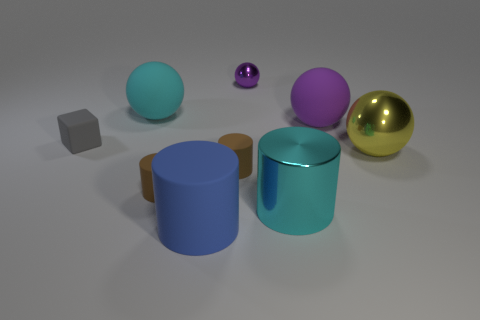What is the material of the tiny purple ball?
Make the answer very short. Metal. There is a purple object that is the same size as the yellow sphere; what is its shape?
Your response must be concise. Sphere. Is there a big rubber cube that has the same color as the tiny shiny sphere?
Your response must be concise. No. Do the big metallic cylinder and the big ball that is on the left side of the purple matte object have the same color?
Give a very brief answer. Yes. There is a small thing behind the large sphere on the left side of the purple metallic object; what color is it?
Keep it short and to the point. Purple. There is a purple ball in front of the shiny object that is behind the yellow shiny thing; are there any spheres behind it?
Your answer should be compact. Yes. What is the color of the big object that is the same material as the cyan cylinder?
Offer a very short reply. Yellow. What number of purple spheres are made of the same material as the blue cylinder?
Your response must be concise. 1. Do the small purple sphere and the brown cylinder that is on the left side of the blue object have the same material?
Provide a short and direct response. No. How many things are either matte things that are in front of the purple rubber thing or small matte things?
Your response must be concise. 4. 